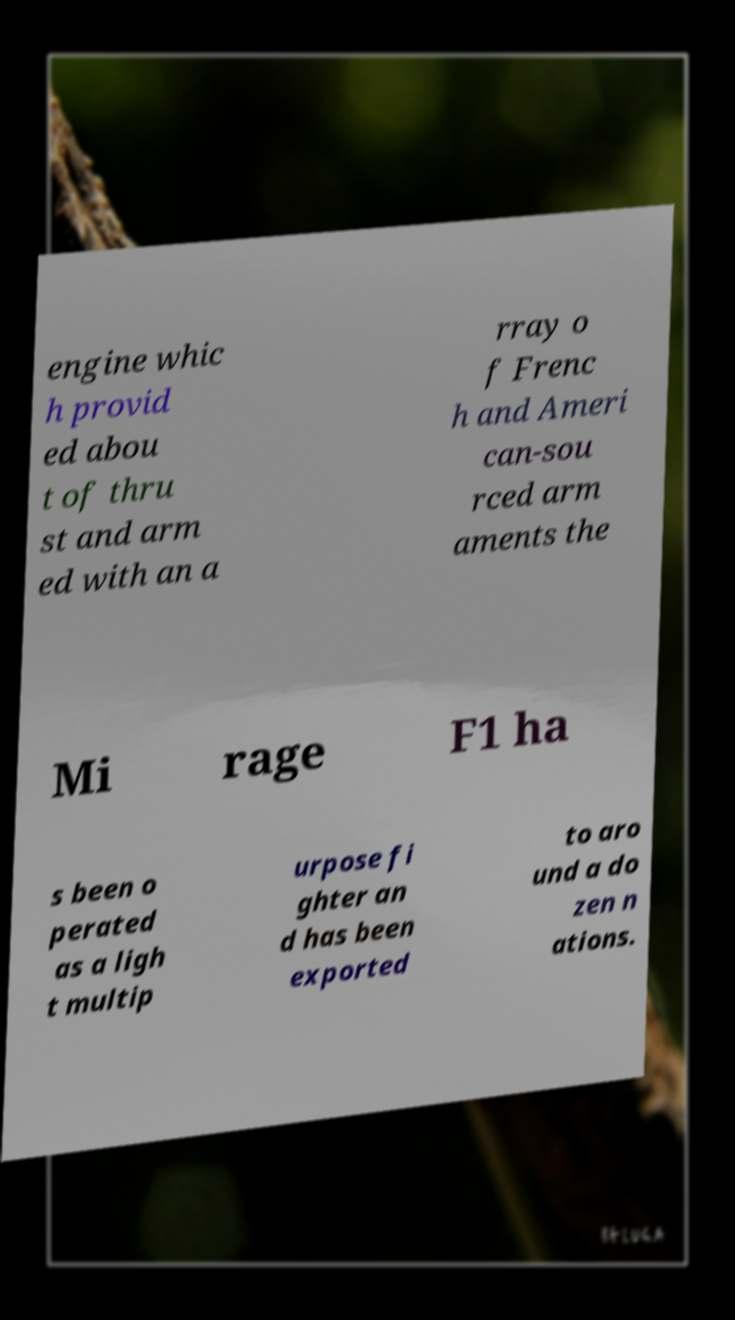Could you assist in decoding the text presented in this image and type it out clearly? engine whic h provid ed abou t of thru st and arm ed with an a rray o f Frenc h and Ameri can-sou rced arm aments the Mi rage F1 ha s been o perated as a ligh t multip urpose fi ghter an d has been exported to aro und a do zen n ations. 